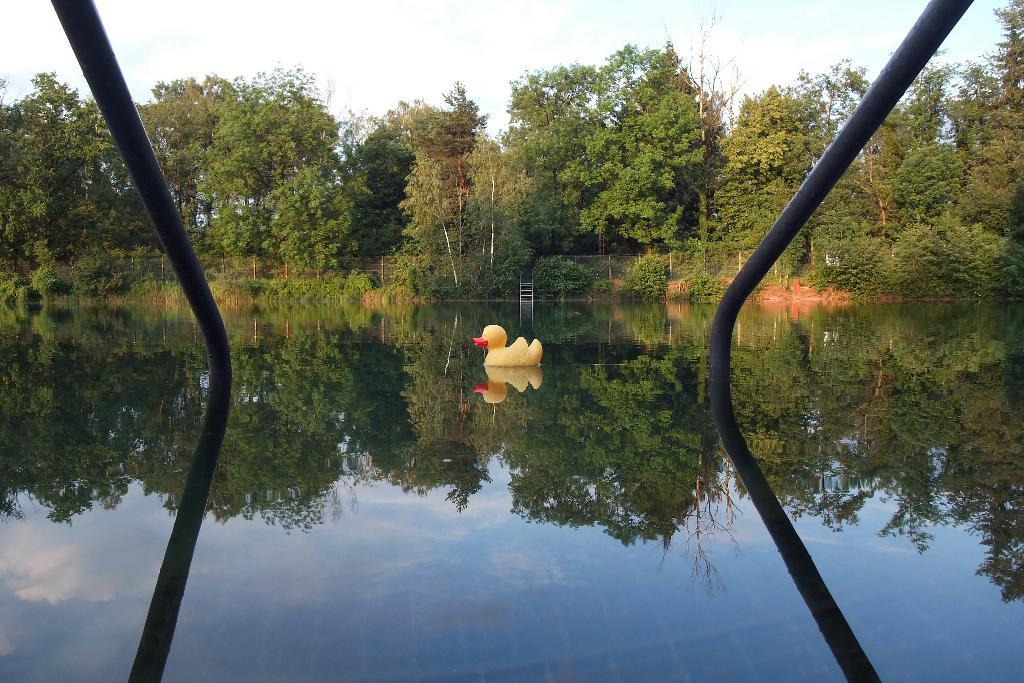What type of toy is in the image? There is a yellow color bird toy in the image. Where is the bird toy located? The bird toy is on the water. What can be seen in the background of the image? There are trees, black color poles, the sky, plants, and other objects in the background of the image. What type of flag is visible in the image? There is no flag present in the image. What color paint is used on the daughter's dress in the image? There is no daughter or dress present in the image. 